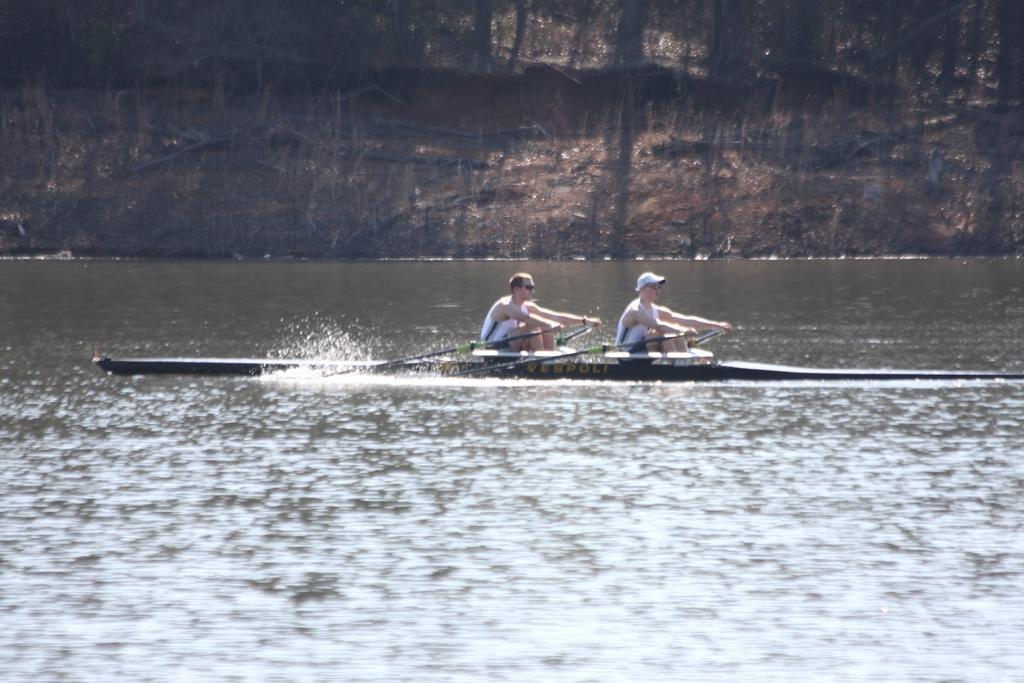How many people are in the image? There are two people in the image. What are the two people doing in the image? The two people are rowing a boat. Where is the boat located in the image? The boat is on the water. What can be seen in the background of the image? There is a hill in the background of the image. How many pencils are floating in the water next to the boat? There are no pencils visible in the image; the only objects in the water are the boat and the two people rowing it. 